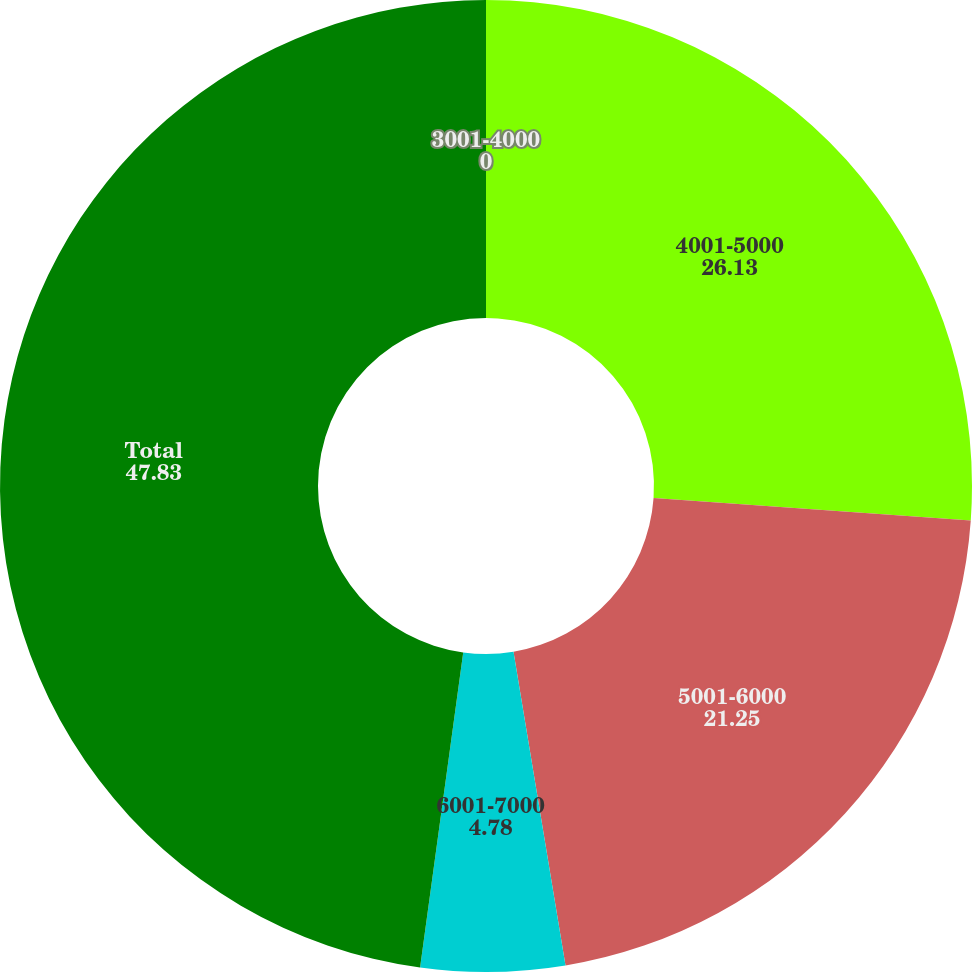<chart> <loc_0><loc_0><loc_500><loc_500><pie_chart><fcel>3001-4000<fcel>4001-5000<fcel>5001-6000<fcel>6001-7000<fcel>Total<nl><fcel>0.0%<fcel>26.13%<fcel>21.25%<fcel>4.78%<fcel>47.83%<nl></chart> 